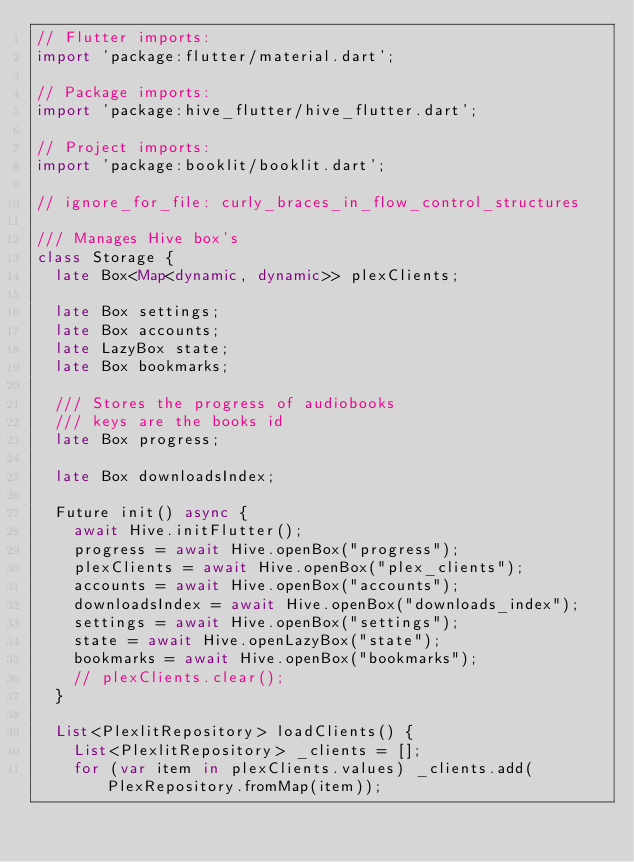<code> <loc_0><loc_0><loc_500><loc_500><_Dart_>// Flutter imports:
import 'package:flutter/material.dart';

// Package imports:
import 'package:hive_flutter/hive_flutter.dart';

// Project imports:
import 'package:booklit/booklit.dart';

// ignore_for_file: curly_braces_in_flow_control_structures

/// Manages Hive box's
class Storage {
  late Box<Map<dynamic, dynamic>> plexClients;

  late Box settings;
  late Box accounts;
  late LazyBox state;
  late Box bookmarks;

  /// Stores the progress of audiobooks
  /// keys are the books id
  late Box progress;

  late Box downloadsIndex;

  Future init() async {
    await Hive.initFlutter();
    progress = await Hive.openBox("progress");
    plexClients = await Hive.openBox("plex_clients");
    accounts = await Hive.openBox("accounts");
    downloadsIndex = await Hive.openBox("downloads_index");
    settings = await Hive.openBox("settings");
    state = await Hive.openLazyBox("state");
    bookmarks = await Hive.openBox("bookmarks");
    // plexClients.clear();
  }

  List<PlexlitRepository> loadClients() {
    List<PlexlitRepository> _clients = [];
    for (var item in plexClients.values) _clients.add(PlexRepository.fromMap(item));
</code> 